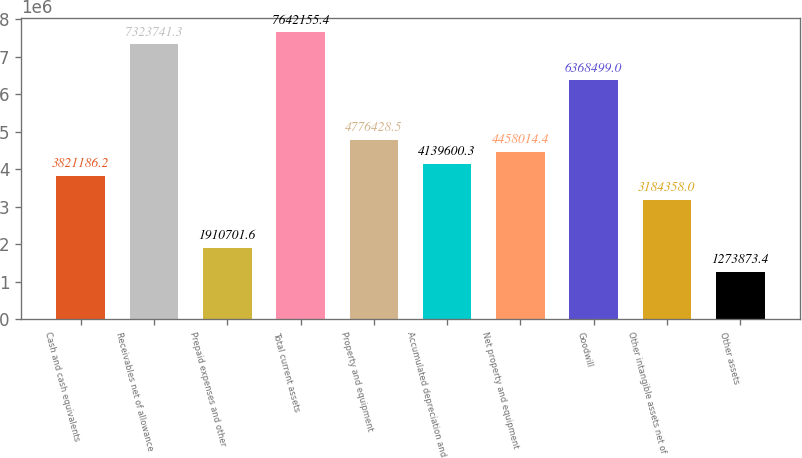<chart> <loc_0><loc_0><loc_500><loc_500><bar_chart><fcel>Cash and cash equivalents<fcel>Receivables net of allowance<fcel>Prepaid expenses and other<fcel>Total current assets<fcel>Property and equipment<fcel>Accumulated depreciation and<fcel>Net property and equipment<fcel>Goodwill<fcel>Other intangible assets net of<fcel>Other assets<nl><fcel>3.82119e+06<fcel>7.32374e+06<fcel>1.9107e+06<fcel>7.64216e+06<fcel>4.77643e+06<fcel>4.1396e+06<fcel>4.45801e+06<fcel>6.3685e+06<fcel>3.18436e+06<fcel>1.27387e+06<nl></chart> 